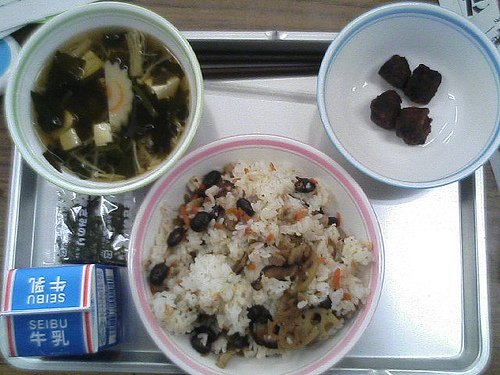<image>
Is there a food on the table? Yes. Looking at the image, I can see the food is positioned on top of the table, with the table providing support. 